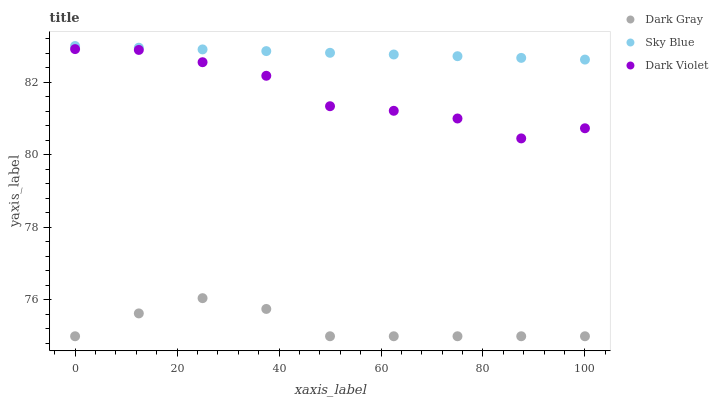Does Dark Gray have the minimum area under the curve?
Answer yes or no. Yes. Does Sky Blue have the maximum area under the curve?
Answer yes or no. Yes. Does Dark Violet have the minimum area under the curve?
Answer yes or no. No. Does Dark Violet have the maximum area under the curve?
Answer yes or no. No. Is Sky Blue the smoothest?
Answer yes or no. Yes. Is Dark Violet the roughest?
Answer yes or no. Yes. Is Dark Violet the smoothest?
Answer yes or no. No. Is Sky Blue the roughest?
Answer yes or no. No. Does Dark Gray have the lowest value?
Answer yes or no. Yes. Does Dark Violet have the lowest value?
Answer yes or no. No. Does Sky Blue have the highest value?
Answer yes or no. Yes. Does Dark Violet have the highest value?
Answer yes or no. No. Is Dark Gray less than Sky Blue?
Answer yes or no. Yes. Is Dark Violet greater than Dark Gray?
Answer yes or no. Yes. Does Dark Gray intersect Sky Blue?
Answer yes or no. No. 